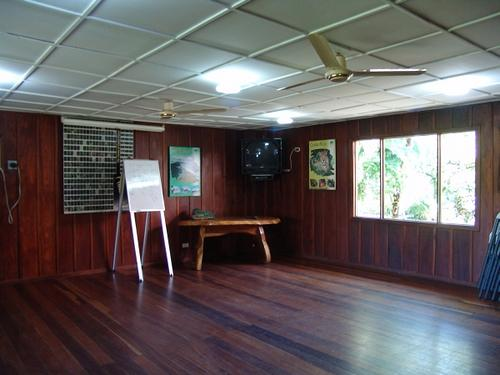What item here would an artist use? easel 